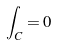<formula> <loc_0><loc_0><loc_500><loc_500>\int _ { C } = 0</formula> 